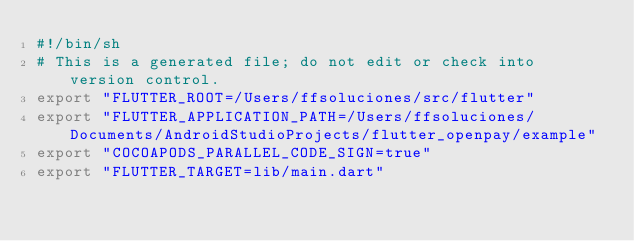<code> <loc_0><loc_0><loc_500><loc_500><_Bash_>#!/bin/sh
# This is a generated file; do not edit or check into version control.
export "FLUTTER_ROOT=/Users/ffsoluciones/src/flutter"
export "FLUTTER_APPLICATION_PATH=/Users/ffsoluciones/Documents/AndroidStudioProjects/flutter_openpay/example"
export "COCOAPODS_PARALLEL_CODE_SIGN=true"
export "FLUTTER_TARGET=lib/main.dart"</code> 